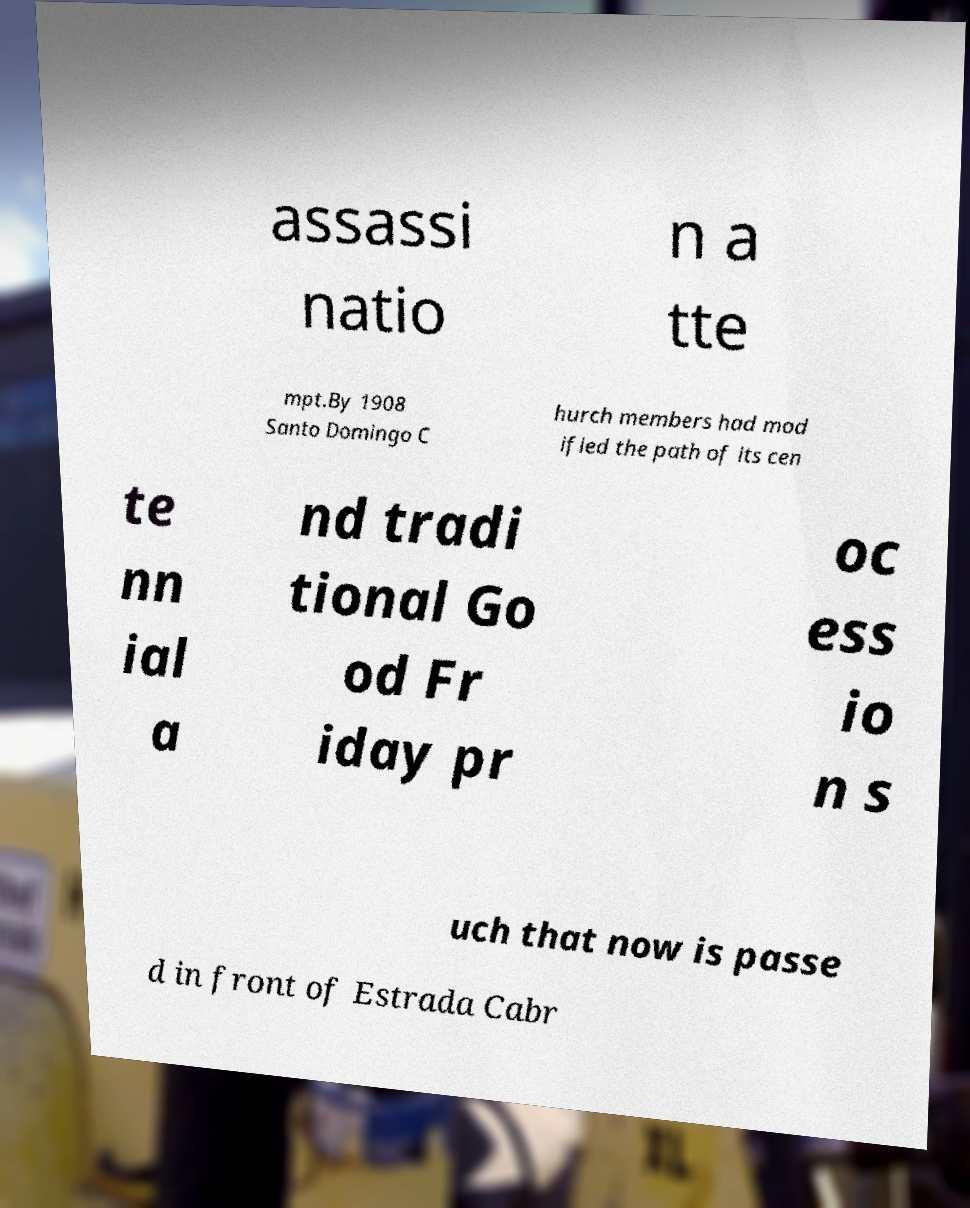I need the written content from this picture converted into text. Can you do that? assassi natio n a tte mpt.By 1908 Santo Domingo C hurch members had mod ified the path of its cen te nn ial a nd tradi tional Go od Fr iday pr oc ess io n s uch that now is passe d in front of Estrada Cabr 